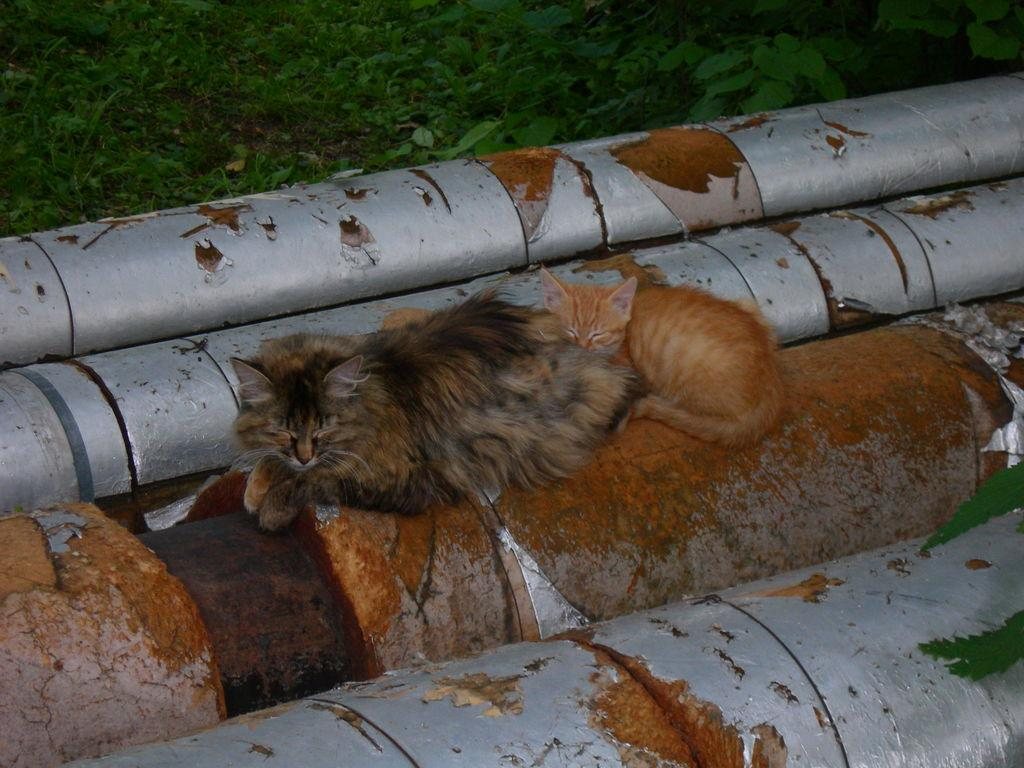What animals are on a pole in the image? There are two cats on a pole in the image. Are there any other poles visible in the image? Yes, there are other poles visible in the image. What type of vegetation is on the ground in the image? There are plants on the ground in the image. Can you see any dinosaurs using a hose to water the plants in the image? No, there are no dinosaurs or hoses present in the image. 